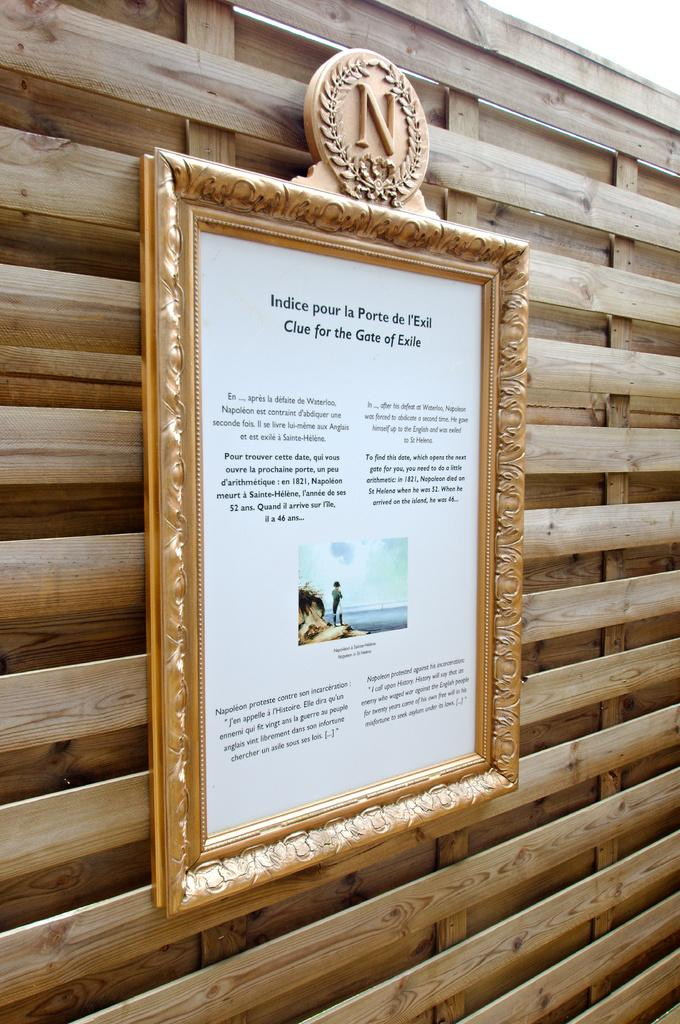<image>
Describe the image concisely. A placard in French language is mounted to a wooden plank wall. 